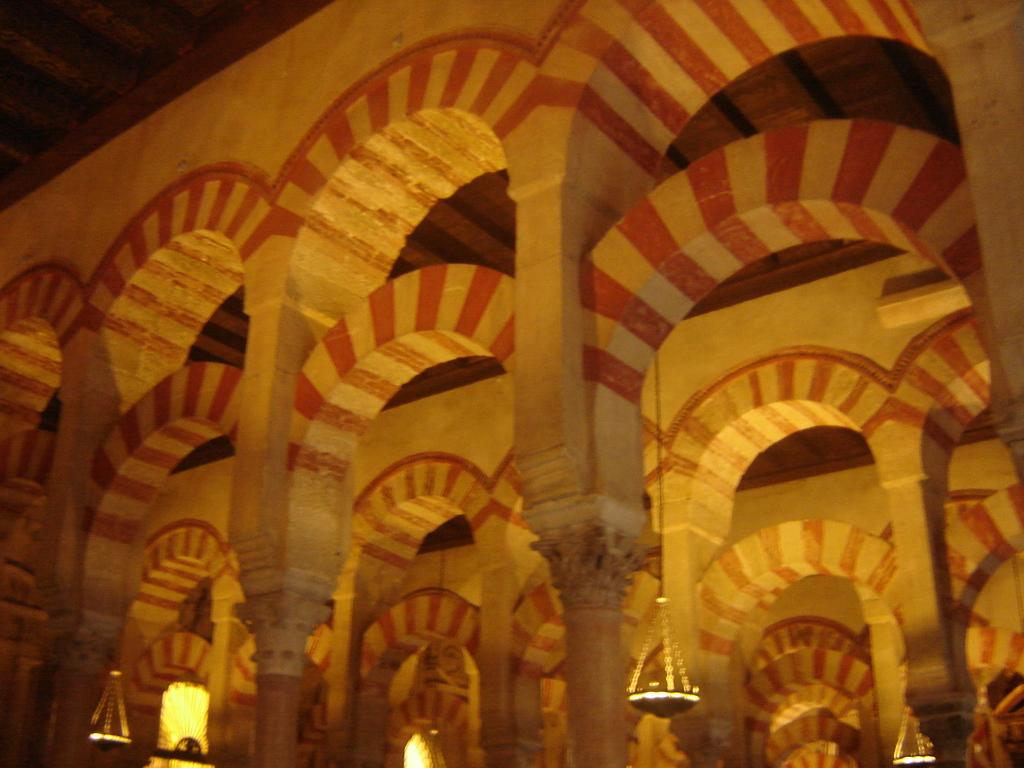What type of architectural feature can be seen in the image? There are pillars in the image. What else can be seen in the image besides the pillars? There is a wall, lights, and other objects visible in the image. What is located at the top of the image? The ceiling is visible at the top of the image. What type of rice is being used as bait in the image? There is no rice or bait present in the image. What is the mass of the objects in the image? The mass of the objects in the image cannot be determined from the image alone. 